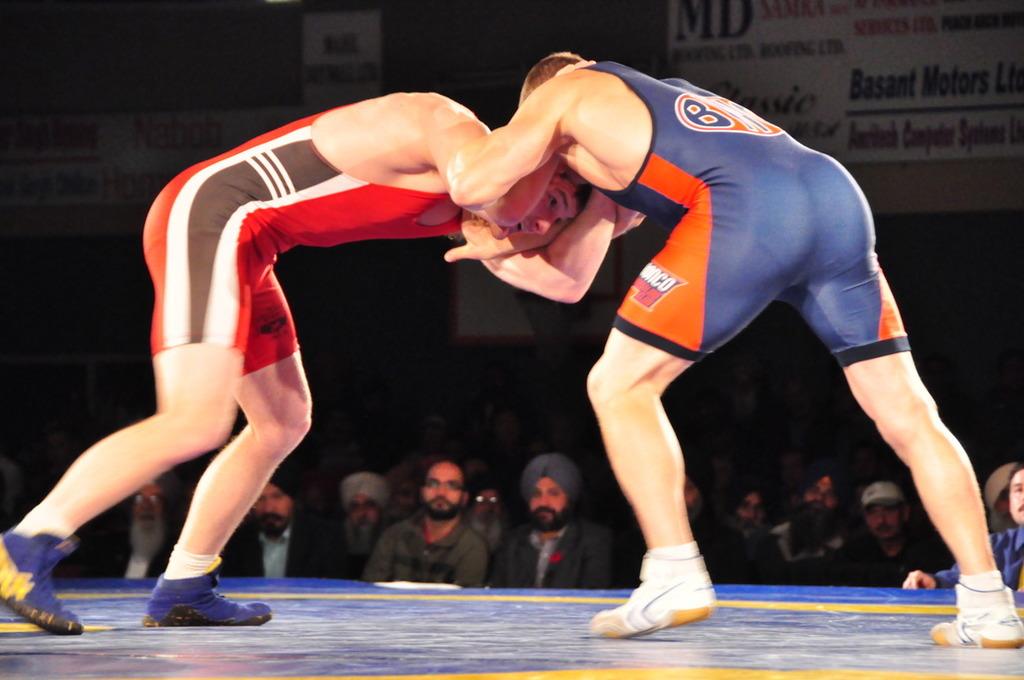What kind of motors is a sponsor?
Offer a terse response. Basant. 